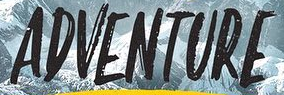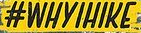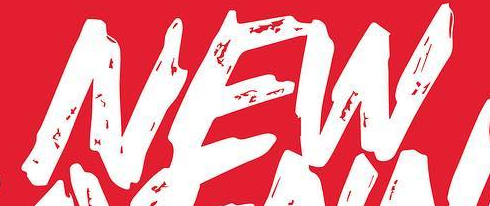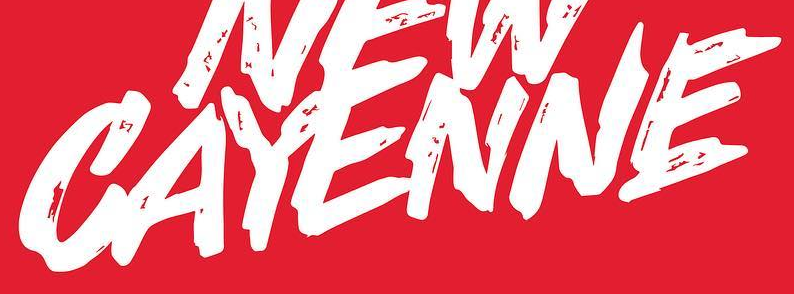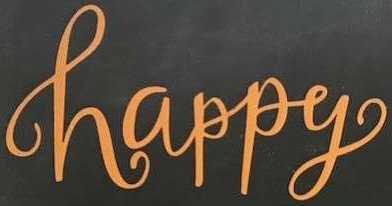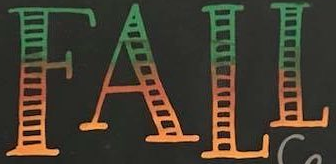What text appears in these images from left to right, separated by a semicolon? ADVENTURE; #WHYIHIKE; NEW; CAYENNE; happy; FALL 